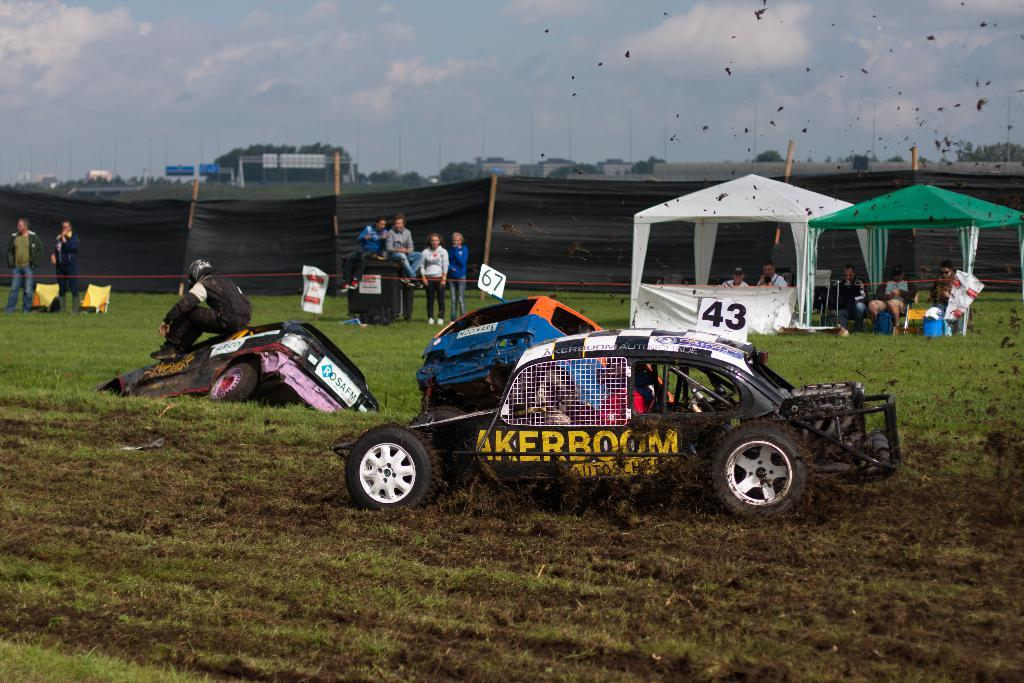What type of vehicles are on the grass in the image? The facts do not specify the type of vehicles, but there are vehicles on the grass in the image. What structures can be seen in the image? There are tents in the image. Can you describe the people visible in the image? The facts do not provide details about the people, but there are people visible in the image. What type of face can be seen on the slave in the image? There is no mention of a slave or a face in the image; the facts only mention vehicles, tents, and people. 